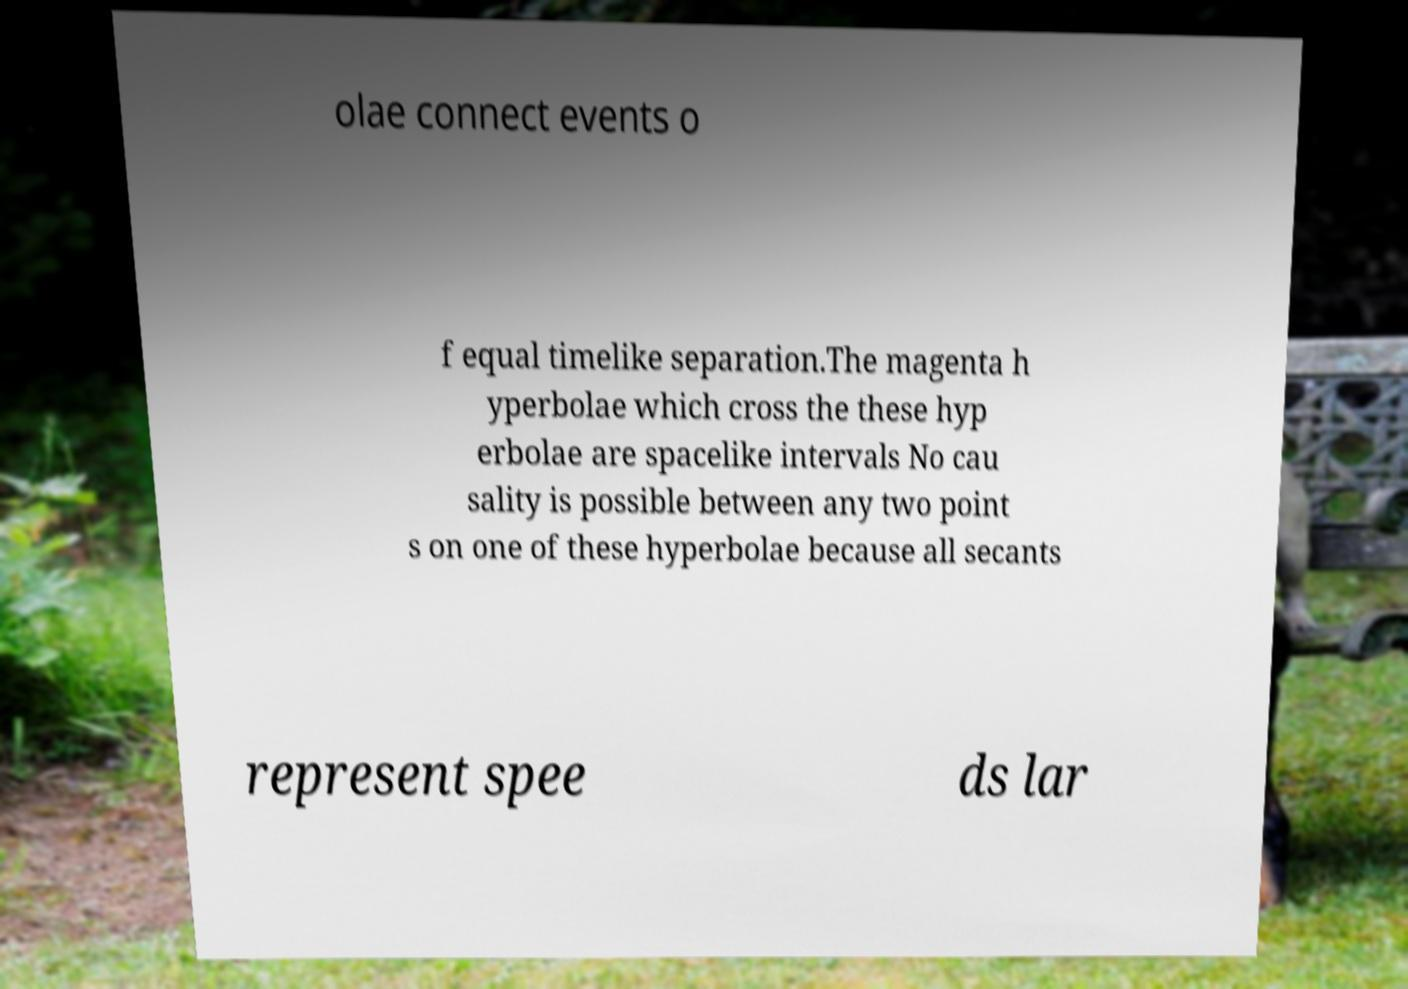There's text embedded in this image that I need extracted. Can you transcribe it verbatim? olae connect events o f equal timelike separation.The magenta h yperbolae which cross the these hyp erbolae are spacelike intervals No cau sality is possible between any two point s on one of these hyperbolae because all secants represent spee ds lar 